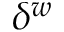<formula> <loc_0><loc_0><loc_500><loc_500>\delta ^ { w }</formula> 